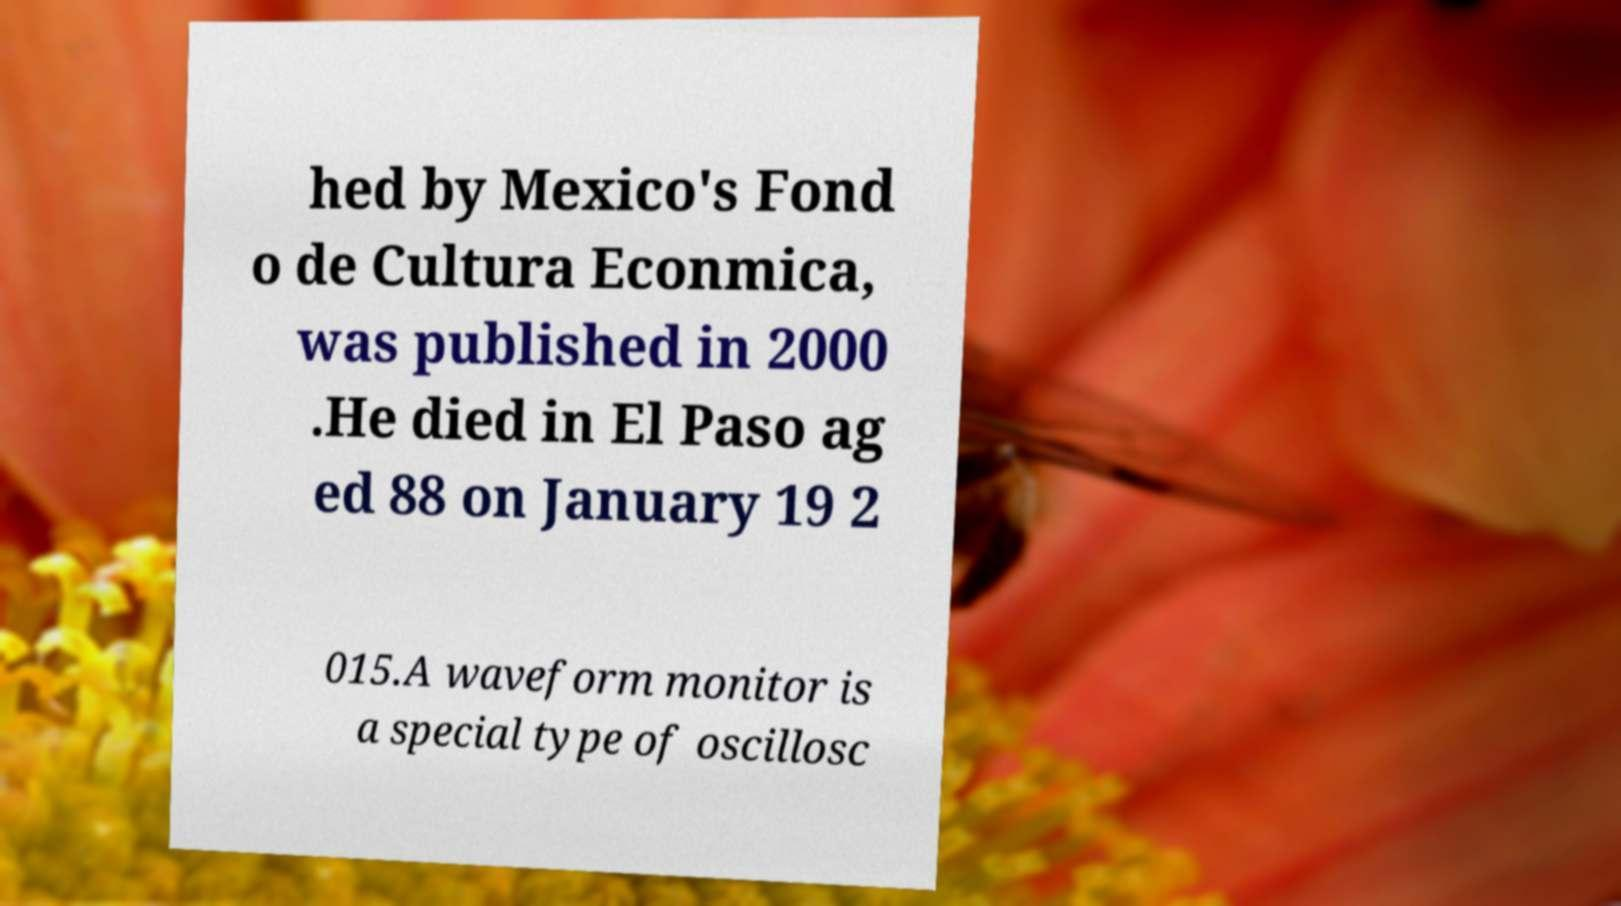Can you read and provide the text displayed in the image?This photo seems to have some interesting text. Can you extract and type it out for me? hed by Mexico's Fond o de Cultura Econmica, was published in 2000 .He died in El Paso ag ed 88 on January 19 2 015.A waveform monitor is a special type of oscillosc 